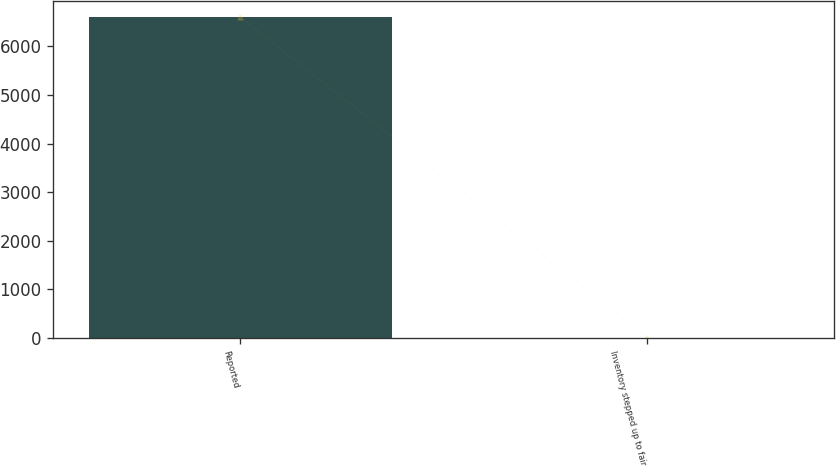<chart> <loc_0><loc_0><loc_500><loc_500><bar_chart><fcel>Reported<fcel>Inventory stepped up to fair<nl><fcel>6602<fcel>7<nl></chart> 